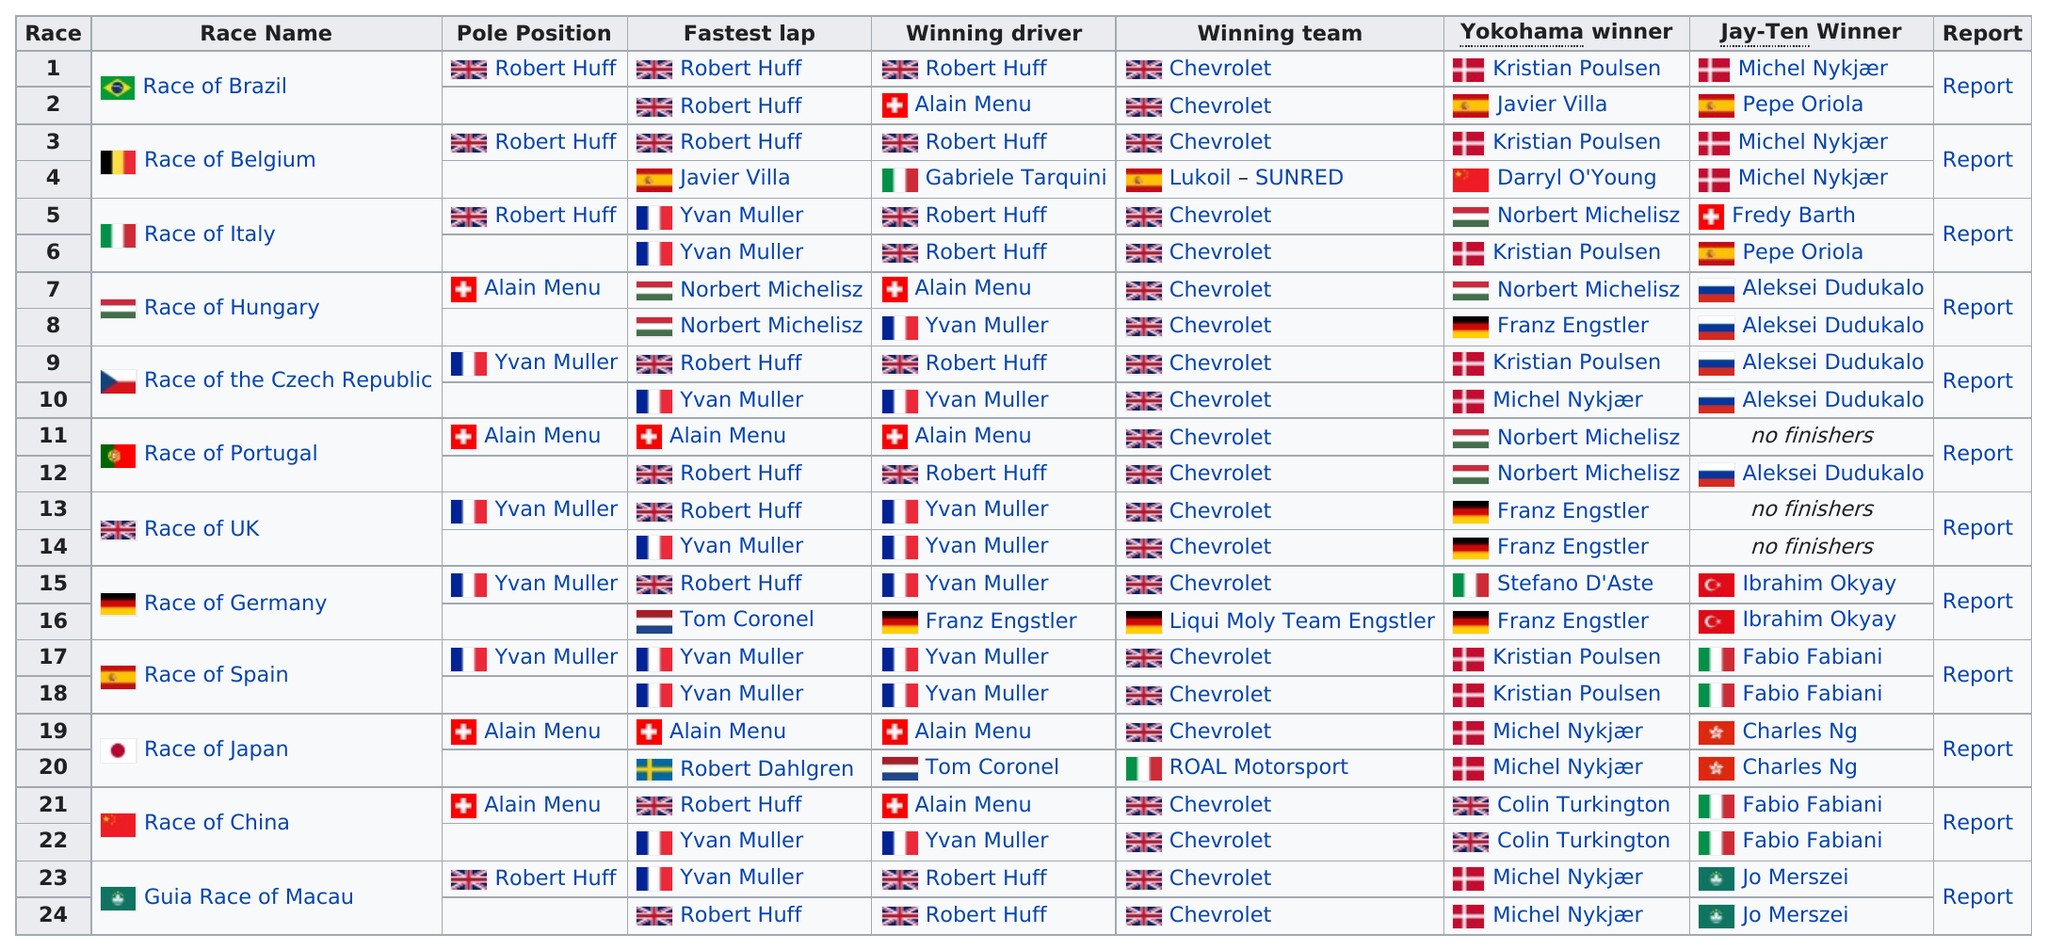Highlight a few significant elements in this photo. The total number of races is 24. Fabio Fabiani is a Jay-Ten winner four times. The team that won the most number of times was Chevrolet. Robert Huff holds the record for having the fastest lap nine times during his racing career. The race of Germany had the only German team win. 